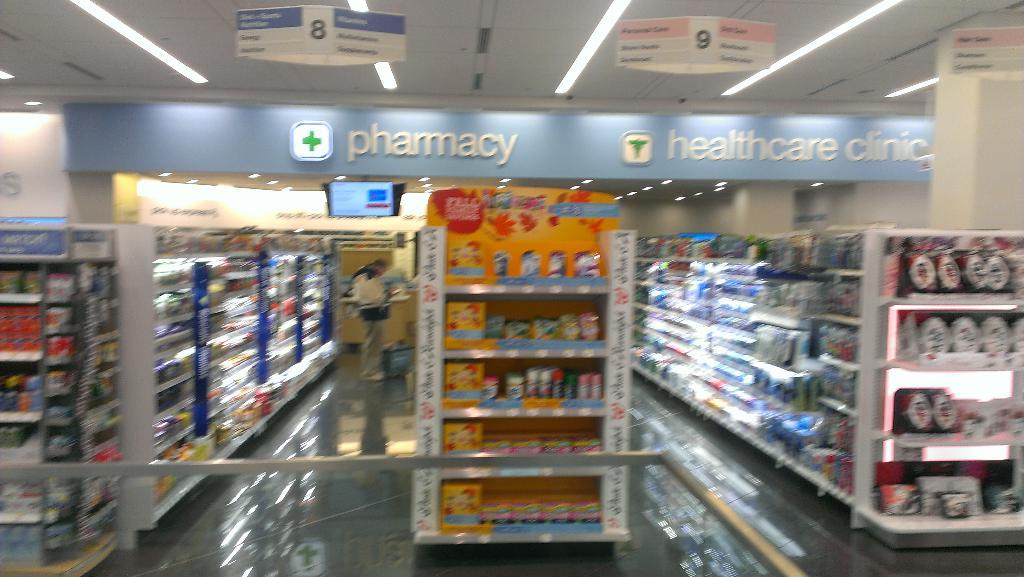Whats next to the green plus at the top left area?
Offer a very short reply. Pharmacy. What department is this?
Your answer should be very brief. Pharmacy. 